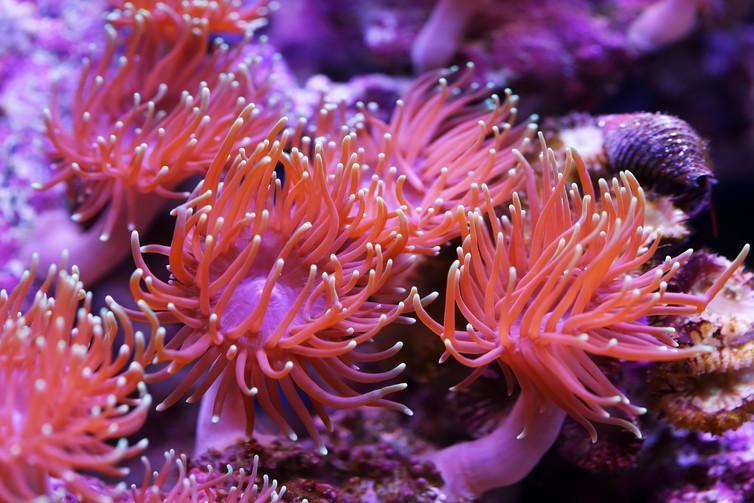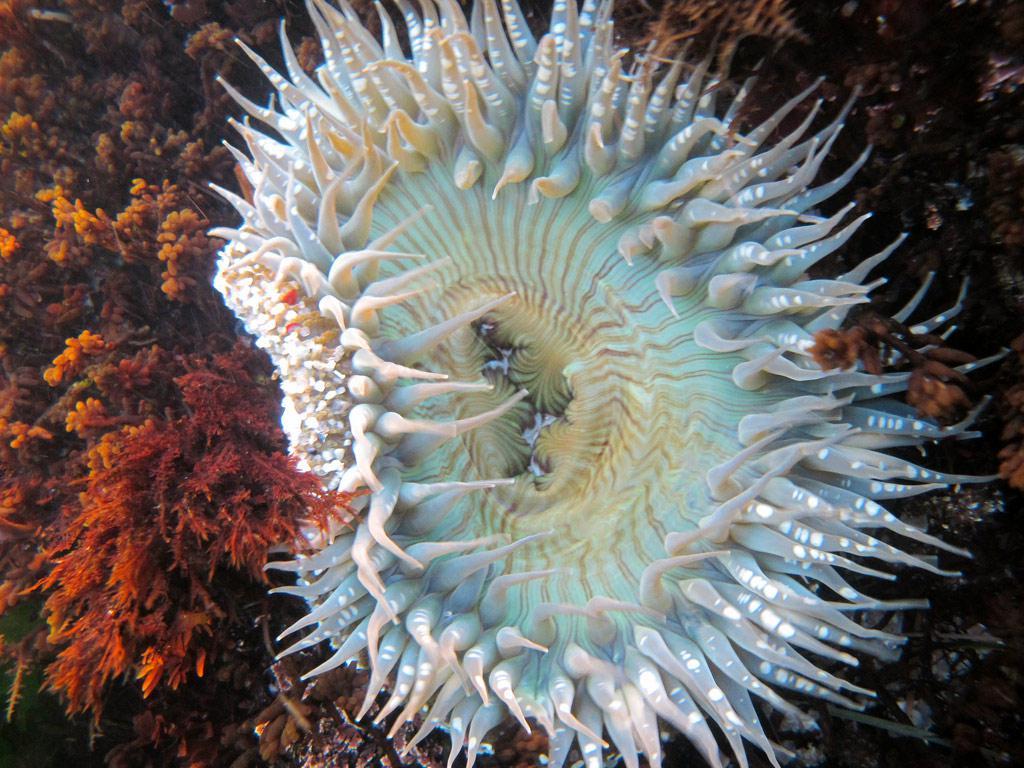The first image is the image on the left, the second image is the image on the right. For the images displayed, is the sentence "There are at least two anemones in one of the images." factually correct? Answer yes or no. Yes. 